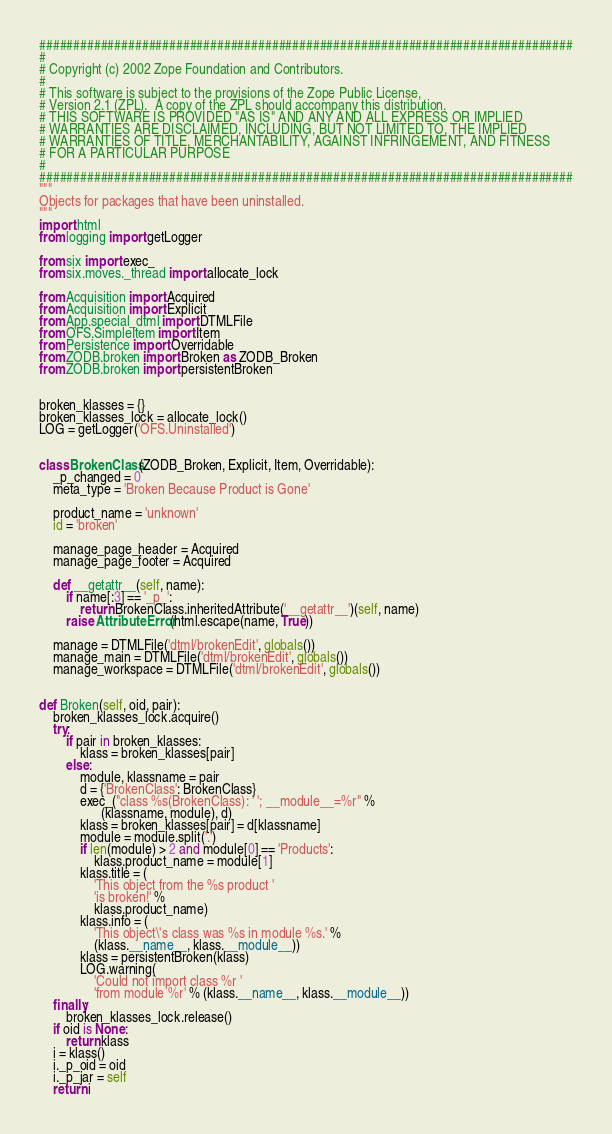<code> <loc_0><loc_0><loc_500><loc_500><_Python_>##############################################################################
#
# Copyright (c) 2002 Zope Foundation and Contributors.
#
# This software is subject to the provisions of the Zope Public License,
# Version 2.1 (ZPL).  A copy of the ZPL should accompany this distribution.
# THIS SOFTWARE IS PROVIDED "AS IS" AND ANY AND ALL EXPRESS OR IMPLIED
# WARRANTIES ARE DISCLAIMED, INCLUDING, BUT NOT LIMITED TO, THE IMPLIED
# WARRANTIES OF TITLE, MERCHANTABILITY, AGAINST INFRINGEMENT, AND FITNESS
# FOR A PARTICULAR PURPOSE
#
##############################################################################
"""
Objects for packages that have been uninstalled.
"""
import html
from logging import getLogger

from six import exec_
from six.moves._thread import allocate_lock

from Acquisition import Acquired
from Acquisition import Explicit
from App.special_dtml import DTMLFile
from OFS.SimpleItem import Item
from Persistence import Overridable
from ZODB.broken import Broken as ZODB_Broken
from ZODB.broken import persistentBroken


broken_klasses = {}
broken_klasses_lock = allocate_lock()
LOG = getLogger('OFS.Uninstalled')


class BrokenClass(ZODB_Broken, Explicit, Item, Overridable):
    _p_changed = 0
    meta_type = 'Broken Because Product is Gone'

    product_name = 'unknown'
    id = 'broken'

    manage_page_header = Acquired
    manage_page_footer = Acquired

    def __getattr__(self, name):
        if name[:3] == '_p_':
            return BrokenClass.inheritedAttribute('__getattr__')(self, name)
        raise AttributeError(html.escape(name, True))

    manage = DTMLFile('dtml/brokenEdit', globals())
    manage_main = DTMLFile('dtml/brokenEdit', globals())
    manage_workspace = DTMLFile('dtml/brokenEdit', globals())


def Broken(self, oid, pair):
    broken_klasses_lock.acquire()
    try:
        if pair in broken_klasses:
            klass = broken_klasses[pair]
        else:
            module, klassname = pair
            d = {'BrokenClass': BrokenClass}
            exec_("class %s(BrokenClass): ' '; __module__=%r" %
                  (klassname, module), d)
            klass = broken_klasses[pair] = d[klassname]
            module = module.split('.')
            if len(module) > 2 and module[0] == 'Products':
                klass.product_name = module[1]
            klass.title = (
                'This object from the %s product '
                'is broken!' %
                klass.product_name)
            klass.info = (
                'This object\'s class was %s in module %s.' %
                (klass.__name__, klass.__module__))
            klass = persistentBroken(klass)
            LOG.warning(
                'Could not import class %r '
                'from module %r' % (klass.__name__, klass.__module__))
    finally:
        broken_klasses_lock.release()
    if oid is None:
        return klass
    i = klass()
    i._p_oid = oid
    i._p_jar = self
    return i
</code> 